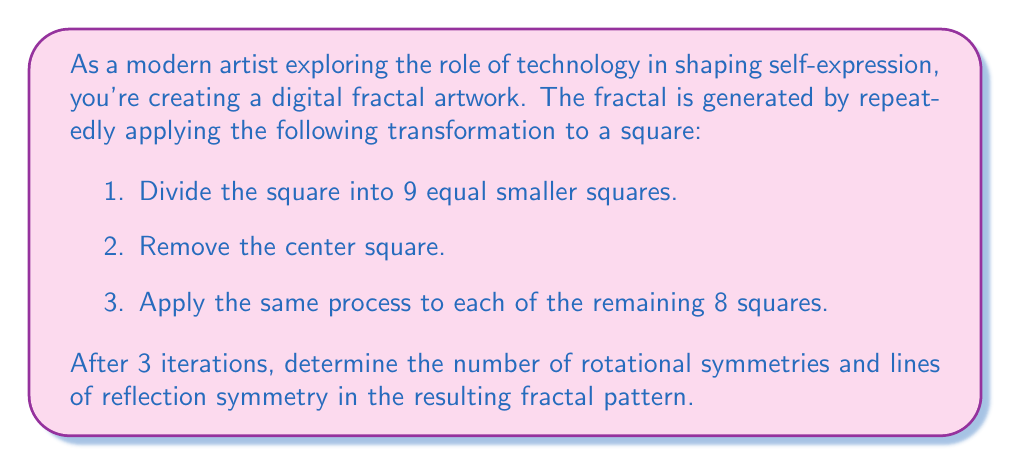Teach me how to tackle this problem. Let's approach this step-by-step:

1. First, let's visualize the fractal after 3 iterations:

[asy]
unitsize(4cm);
void drawFractal(pair center, real size, int depth) {
    if(depth == 0) {
        fill(center - (size/2,size/2) -- center + (size/2,-size/2) -- center + (size/2,size/2) -- center + (-size/2,size/2) -- cycle, gray);
    } else {
        real newSize = size/3;
        for(int i = -1; i <= 1; ++i) {
            for(int j = -1; j <= 1; ++j) {
                if(i != 0 || j != 0) {
                    drawFractal(center + (i*newSize, j*newSize), newSize, depth-1);
                }
            }
        }
    }
}
drawFractal((0,0), 1, 3);
draw((-0.5,-0.5)--(0.5,-0.5)--(0.5,0.5)--(-0.5,0.5)--cycle);
[/asy]

2. Rotational Symmetry:
   - The fractal has 4-fold rotational symmetry, meaning it looks the same when rotated by 90°, 180°, 270°, and 360°.
   - Therefore, it has 4 rotational symmetries.

3. Reflection Symmetry:
   - The fractal has 4 lines of reflection symmetry:
     a. Vertical line through the center
     b. Horizontal line through the center
     c. Diagonal line from top-left to bottom-right
     d. Diagonal line from top-right to bottom-left

To verify these symmetries, we can imagine folding the fractal along these lines or rotating it around its center. The pattern remains unchanged, confirming the symmetries.

The symmetry of this fractal is a result of its recursive construction process and the square shape it's based on. This symmetry contributes to the aesthetic appeal of the fractal, making it an interesting subject for artistic exploration in the intersection of mathematics and digital art.
Answer: The fractal has 4 rotational symmetries and 4 lines of reflection symmetry. 